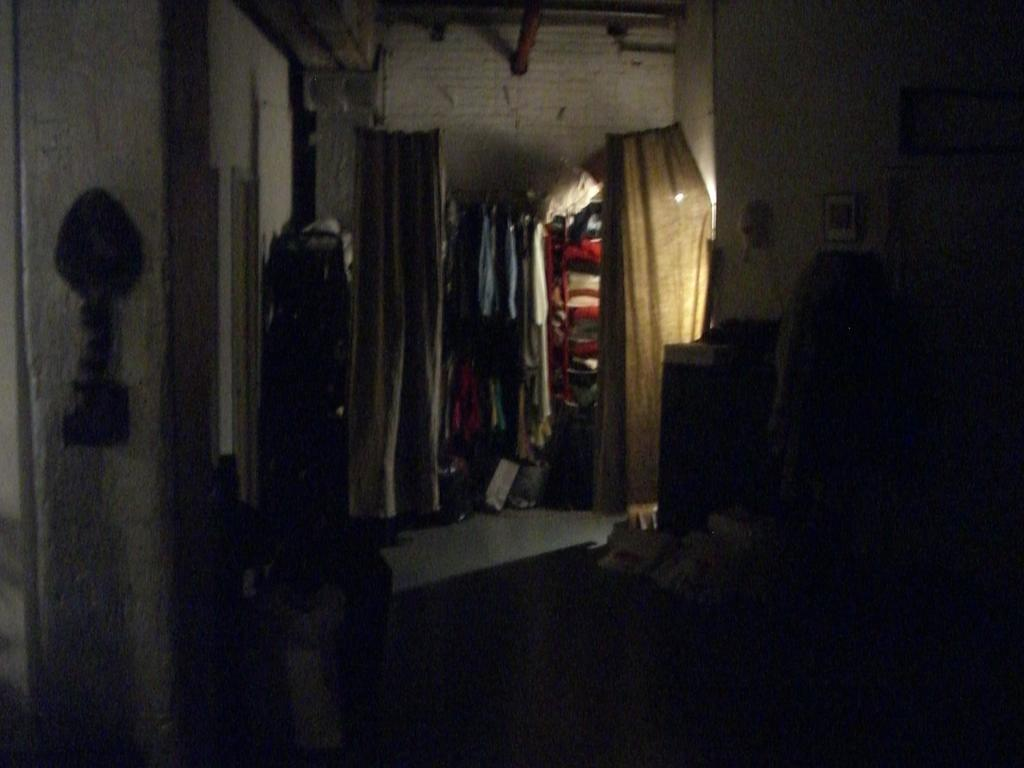Where was the image taken? The image was taken indoors. Can you describe the lighting in the image? The image is a little dark. What can be seen in the background of the image? There are walls visible in the background. What is present in the image besides the walls? There are clothes and objects present in the image. How does the wind affect the clothes in the image? There is no wind present in the image, as it was taken indoors. What type of footwear is the writer wearing in the image? There is no writer or footwear present in the image; it only features clothes and objects. 